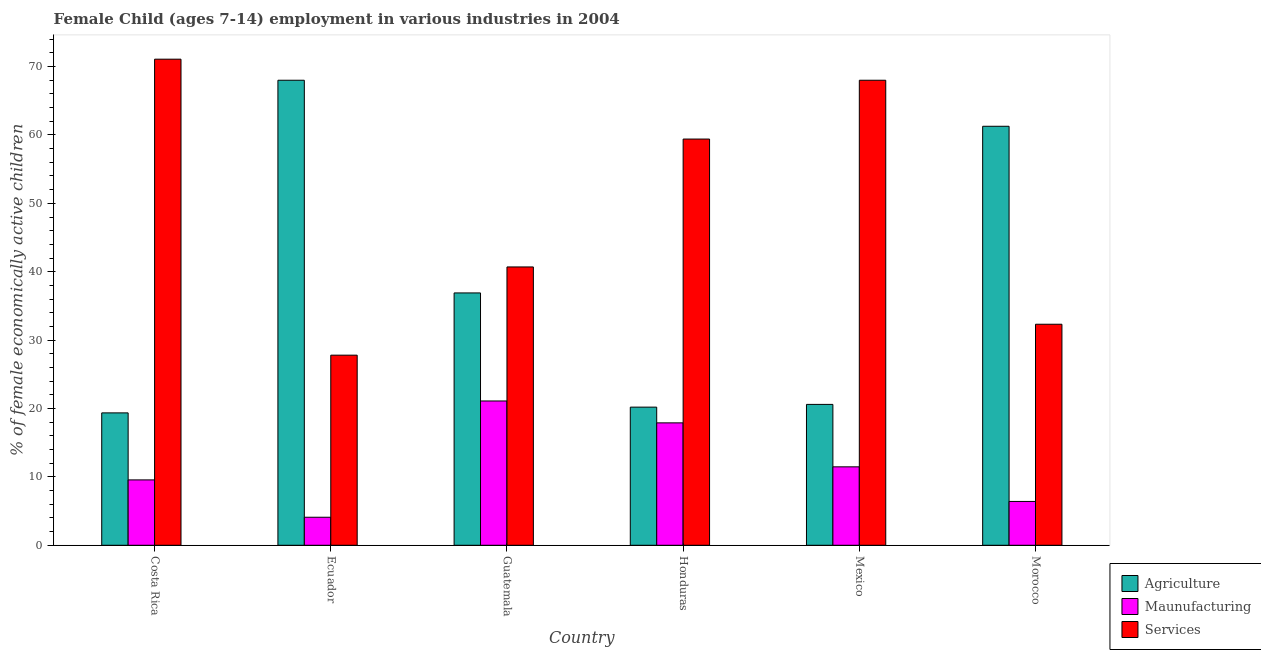How many different coloured bars are there?
Your answer should be compact. 3. Are the number of bars per tick equal to the number of legend labels?
Give a very brief answer. Yes. Are the number of bars on each tick of the X-axis equal?
Your answer should be very brief. Yes. How many bars are there on the 1st tick from the left?
Ensure brevity in your answer.  3. How many bars are there on the 2nd tick from the right?
Provide a short and direct response. 3. In how many cases, is the number of bars for a given country not equal to the number of legend labels?
Keep it short and to the point. 0. What is the percentage of economically active children in manufacturing in Morocco?
Ensure brevity in your answer.  6.41. Across all countries, what is the maximum percentage of economically active children in manufacturing?
Make the answer very short. 21.1. In which country was the percentage of economically active children in services minimum?
Offer a terse response. Ecuador. What is the total percentage of economically active children in agriculture in the graph?
Keep it short and to the point. 226.33. What is the difference between the percentage of economically active children in manufacturing in Guatemala and that in Honduras?
Your answer should be compact. 3.2. What is the difference between the percentage of economically active children in manufacturing in Honduras and the percentage of economically active children in agriculture in Guatemala?
Provide a succinct answer. -19. What is the average percentage of economically active children in services per country?
Your answer should be compact. 49.88. What is the difference between the percentage of economically active children in services and percentage of economically active children in agriculture in Costa Rica?
Ensure brevity in your answer.  51.72. In how many countries, is the percentage of economically active children in manufacturing greater than 46 %?
Provide a short and direct response. 0. What is the ratio of the percentage of economically active children in services in Ecuador to that in Honduras?
Give a very brief answer. 0.47. Is the percentage of economically active children in manufacturing in Ecuador less than that in Mexico?
Ensure brevity in your answer.  Yes. What is the difference between the highest and the second highest percentage of economically active children in agriculture?
Provide a short and direct response. 6.73. What is the difference between the highest and the lowest percentage of economically active children in manufacturing?
Make the answer very short. 17. In how many countries, is the percentage of economically active children in services greater than the average percentage of economically active children in services taken over all countries?
Provide a short and direct response. 3. Is the sum of the percentage of economically active children in agriculture in Ecuador and Mexico greater than the maximum percentage of economically active children in services across all countries?
Keep it short and to the point. Yes. What does the 3rd bar from the left in Morocco represents?
Your answer should be compact. Services. What does the 1st bar from the right in Mexico represents?
Offer a terse response. Services. How many bars are there?
Give a very brief answer. 18. Are the values on the major ticks of Y-axis written in scientific E-notation?
Your response must be concise. No. Does the graph contain grids?
Ensure brevity in your answer.  No. How many legend labels are there?
Provide a succinct answer. 3. How are the legend labels stacked?
Offer a terse response. Vertical. What is the title of the graph?
Provide a succinct answer. Female Child (ages 7-14) employment in various industries in 2004. Does "Injury" appear as one of the legend labels in the graph?
Give a very brief answer. No. What is the label or title of the Y-axis?
Your answer should be compact. % of female economically active children. What is the % of female economically active children in Agriculture in Costa Rica?
Keep it short and to the point. 19.36. What is the % of female economically active children of Maunufacturing in Costa Rica?
Your answer should be compact. 9.56. What is the % of female economically active children of Services in Costa Rica?
Your response must be concise. 71.08. What is the % of female economically active children in Agriculture in Ecuador?
Keep it short and to the point. 68. What is the % of female economically active children of Maunufacturing in Ecuador?
Offer a terse response. 4.1. What is the % of female economically active children of Services in Ecuador?
Provide a short and direct response. 27.8. What is the % of female economically active children of Agriculture in Guatemala?
Provide a succinct answer. 36.9. What is the % of female economically active children in Maunufacturing in Guatemala?
Offer a terse response. 21.1. What is the % of female economically active children in Services in Guatemala?
Your response must be concise. 40.7. What is the % of female economically active children in Agriculture in Honduras?
Provide a succinct answer. 20.2. What is the % of female economically active children in Services in Honduras?
Your response must be concise. 59.4. What is the % of female economically active children of Agriculture in Mexico?
Provide a short and direct response. 20.6. What is the % of female economically active children of Maunufacturing in Mexico?
Offer a very short reply. 11.47. What is the % of female economically active children of Agriculture in Morocco?
Your response must be concise. 61.27. What is the % of female economically active children in Maunufacturing in Morocco?
Keep it short and to the point. 6.41. What is the % of female economically active children in Services in Morocco?
Your answer should be very brief. 32.32. Across all countries, what is the maximum % of female economically active children in Maunufacturing?
Ensure brevity in your answer.  21.1. Across all countries, what is the maximum % of female economically active children of Services?
Offer a very short reply. 71.08. Across all countries, what is the minimum % of female economically active children of Agriculture?
Keep it short and to the point. 19.36. Across all countries, what is the minimum % of female economically active children of Maunufacturing?
Keep it short and to the point. 4.1. Across all countries, what is the minimum % of female economically active children of Services?
Offer a very short reply. 27.8. What is the total % of female economically active children of Agriculture in the graph?
Your response must be concise. 226.33. What is the total % of female economically active children of Maunufacturing in the graph?
Offer a very short reply. 70.54. What is the total % of female economically active children of Services in the graph?
Ensure brevity in your answer.  299.3. What is the difference between the % of female economically active children of Agriculture in Costa Rica and that in Ecuador?
Provide a succinct answer. -48.64. What is the difference between the % of female economically active children of Maunufacturing in Costa Rica and that in Ecuador?
Your answer should be compact. 5.46. What is the difference between the % of female economically active children in Services in Costa Rica and that in Ecuador?
Offer a very short reply. 43.28. What is the difference between the % of female economically active children of Agriculture in Costa Rica and that in Guatemala?
Your answer should be compact. -17.54. What is the difference between the % of female economically active children of Maunufacturing in Costa Rica and that in Guatemala?
Make the answer very short. -11.54. What is the difference between the % of female economically active children in Services in Costa Rica and that in Guatemala?
Your answer should be compact. 30.38. What is the difference between the % of female economically active children of Agriculture in Costa Rica and that in Honduras?
Your answer should be compact. -0.84. What is the difference between the % of female economically active children of Maunufacturing in Costa Rica and that in Honduras?
Provide a succinct answer. -8.34. What is the difference between the % of female economically active children in Services in Costa Rica and that in Honduras?
Your answer should be compact. 11.68. What is the difference between the % of female economically active children in Agriculture in Costa Rica and that in Mexico?
Your answer should be compact. -1.24. What is the difference between the % of female economically active children of Maunufacturing in Costa Rica and that in Mexico?
Provide a succinct answer. -1.91. What is the difference between the % of female economically active children of Services in Costa Rica and that in Mexico?
Provide a short and direct response. 3.08. What is the difference between the % of female economically active children of Agriculture in Costa Rica and that in Morocco?
Your answer should be compact. -41.91. What is the difference between the % of female economically active children of Maunufacturing in Costa Rica and that in Morocco?
Give a very brief answer. 3.15. What is the difference between the % of female economically active children in Services in Costa Rica and that in Morocco?
Ensure brevity in your answer.  38.76. What is the difference between the % of female economically active children of Agriculture in Ecuador and that in Guatemala?
Offer a very short reply. 31.1. What is the difference between the % of female economically active children of Maunufacturing in Ecuador and that in Guatemala?
Your answer should be compact. -17. What is the difference between the % of female economically active children in Services in Ecuador and that in Guatemala?
Your response must be concise. -12.9. What is the difference between the % of female economically active children in Agriculture in Ecuador and that in Honduras?
Your response must be concise. 47.8. What is the difference between the % of female economically active children of Maunufacturing in Ecuador and that in Honduras?
Offer a very short reply. -13.8. What is the difference between the % of female economically active children of Services in Ecuador and that in Honduras?
Give a very brief answer. -31.6. What is the difference between the % of female economically active children in Agriculture in Ecuador and that in Mexico?
Make the answer very short. 47.4. What is the difference between the % of female economically active children of Maunufacturing in Ecuador and that in Mexico?
Give a very brief answer. -7.37. What is the difference between the % of female economically active children in Services in Ecuador and that in Mexico?
Offer a very short reply. -40.2. What is the difference between the % of female economically active children in Agriculture in Ecuador and that in Morocco?
Offer a very short reply. 6.73. What is the difference between the % of female economically active children of Maunufacturing in Ecuador and that in Morocco?
Make the answer very short. -2.31. What is the difference between the % of female economically active children in Services in Ecuador and that in Morocco?
Make the answer very short. -4.52. What is the difference between the % of female economically active children in Agriculture in Guatemala and that in Honduras?
Your answer should be compact. 16.7. What is the difference between the % of female economically active children of Services in Guatemala and that in Honduras?
Ensure brevity in your answer.  -18.7. What is the difference between the % of female economically active children in Maunufacturing in Guatemala and that in Mexico?
Give a very brief answer. 9.63. What is the difference between the % of female economically active children of Services in Guatemala and that in Mexico?
Offer a terse response. -27.3. What is the difference between the % of female economically active children in Agriculture in Guatemala and that in Morocco?
Make the answer very short. -24.37. What is the difference between the % of female economically active children in Maunufacturing in Guatemala and that in Morocco?
Provide a succinct answer. 14.69. What is the difference between the % of female economically active children in Services in Guatemala and that in Morocco?
Offer a terse response. 8.38. What is the difference between the % of female economically active children in Agriculture in Honduras and that in Mexico?
Offer a very short reply. -0.4. What is the difference between the % of female economically active children in Maunufacturing in Honduras and that in Mexico?
Make the answer very short. 6.43. What is the difference between the % of female economically active children in Agriculture in Honduras and that in Morocco?
Provide a short and direct response. -41.07. What is the difference between the % of female economically active children in Maunufacturing in Honduras and that in Morocco?
Keep it short and to the point. 11.49. What is the difference between the % of female economically active children in Services in Honduras and that in Morocco?
Offer a terse response. 27.08. What is the difference between the % of female economically active children in Agriculture in Mexico and that in Morocco?
Your answer should be compact. -40.67. What is the difference between the % of female economically active children in Maunufacturing in Mexico and that in Morocco?
Your response must be concise. 5.06. What is the difference between the % of female economically active children of Services in Mexico and that in Morocco?
Your answer should be compact. 35.68. What is the difference between the % of female economically active children in Agriculture in Costa Rica and the % of female economically active children in Maunufacturing in Ecuador?
Provide a succinct answer. 15.26. What is the difference between the % of female economically active children of Agriculture in Costa Rica and the % of female economically active children of Services in Ecuador?
Keep it short and to the point. -8.44. What is the difference between the % of female economically active children of Maunufacturing in Costa Rica and the % of female economically active children of Services in Ecuador?
Offer a very short reply. -18.24. What is the difference between the % of female economically active children of Agriculture in Costa Rica and the % of female economically active children of Maunufacturing in Guatemala?
Keep it short and to the point. -1.74. What is the difference between the % of female economically active children in Agriculture in Costa Rica and the % of female economically active children in Services in Guatemala?
Your answer should be very brief. -21.34. What is the difference between the % of female economically active children of Maunufacturing in Costa Rica and the % of female economically active children of Services in Guatemala?
Ensure brevity in your answer.  -31.14. What is the difference between the % of female economically active children of Agriculture in Costa Rica and the % of female economically active children of Maunufacturing in Honduras?
Keep it short and to the point. 1.46. What is the difference between the % of female economically active children in Agriculture in Costa Rica and the % of female economically active children in Services in Honduras?
Make the answer very short. -40.04. What is the difference between the % of female economically active children of Maunufacturing in Costa Rica and the % of female economically active children of Services in Honduras?
Your answer should be very brief. -49.84. What is the difference between the % of female economically active children of Agriculture in Costa Rica and the % of female economically active children of Maunufacturing in Mexico?
Your response must be concise. 7.89. What is the difference between the % of female economically active children of Agriculture in Costa Rica and the % of female economically active children of Services in Mexico?
Provide a short and direct response. -48.64. What is the difference between the % of female economically active children in Maunufacturing in Costa Rica and the % of female economically active children in Services in Mexico?
Offer a very short reply. -58.44. What is the difference between the % of female economically active children in Agriculture in Costa Rica and the % of female economically active children in Maunufacturing in Morocco?
Ensure brevity in your answer.  12.95. What is the difference between the % of female economically active children in Agriculture in Costa Rica and the % of female economically active children in Services in Morocco?
Your answer should be very brief. -12.96. What is the difference between the % of female economically active children in Maunufacturing in Costa Rica and the % of female economically active children in Services in Morocco?
Your answer should be very brief. -22.76. What is the difference between the % of female economically active children in Agriculture in Ecuador and the % of female economically active children in Maunufacturing in Guatemala?
Keep it short and to the point. 46.9. What is the difference between the % of female economically active children of Agriculture in Ecuador and the % of female economically active children of Services in Guatemala?
Make the answer very short. 27.3. What is the difference between the % of female economically active children in Maunufacturing in Ecuador and the % of female economically active children in Services in Guatemala?
Your answer should be very brief. -36.6. What is the difference between the % of female economically active children of Agriculture in Ecuador and the % of female economically active children of Maunufacturing in Honduras?
Keep it short and to the point. 50.1. What is the difference between the % of female economically active children of Maunufacturing in Ecuador and the % of female economically active children of Services in Honduras?
Give a very brief answer. -55.3. What is the difference between the % of female economically active children of Agriculture in Ecuador and the % of female economically active children of Maunufacturing in Mexico?
Your response must be concise. 56.53. What is the difference between the % of female economically active children in Agriculture in Ecuador and the % of female economically active children in Services in Mexico?
Your answer should be very brief. 0. What is the difference between the % of female economically active children in Maunufacturing in Ecuador and the % of female economically active children in Services in Mexico?
Provide a short and direct response. -63.9. What is the difference between the % of female economically active children in Agriculture in Ecuador and the % of female economically active children in Maunufacturing in Morocco?
Your answer should be compact. 61.59. What is the difference between the % of female economically active children of Agriculture in Ecuador and the % of female economically active children of Services in Morocco?
Offer a very short reply. 35.68. What is the difference between the % of female economically active children in Maunufacturing in Ecuador and the % of female economically active children in Services in Morocco?
Offer a terse response. -28.22. What is the difference between the % of female economically active children in Agriculture in Guatemala and the % of female economically active children in Services in Honduras?
Your response must be concise. -22.5. What is the difference between the % of female economically active children of Maunufacturing in Guatemala and the % of female economically active children of Services in Honduras?
Offer a very short reply. -38.3. What is the difference between the % of female economically active children of Agriculture in Guatemala and the % of female economically active children of Maunufacturing in Mexico?
Give a very brief answer. 25.43. What is the difference between the % of female economically active children of Agriculture in Guatemala and the % of female economically active children of Services in Mexico?
Make the answer very short. -31.1. What is the difference between the % of female economically active children in Maunufacturing in Guatemala and the % of female economically active children in Services in Mexico?
Provide a short and direct response. -46.9. What is the difference between the % of female economically active children of Agriculture in Guatemala and the % of female economically active children of Maunufacturing in Morocco?
Keep it short and to the point. 30.49. What is the difference between the % of female economically active children in Agriculture in Guatemala and the % of female economically active children in Services in Morocco?
Offer a very short reply. 4.58. What is the difference between the % of female economically active children in Maunufacturing in Guatemala and the % of female economically active children in Services in Morocco?
Offer a terse response. -11.22. What is the difference between the % of female economically active children of Agriculture in Honduras and the % of female economically active children of Maunufacturing in Mexico?
Your response must be concise. 8.73. What is the difference between the % of female economically active children in Agriculture in Honduras and the % of female economically active children in Services in Mexico?
Give a very brief answer. -47.8. What is the difference between the % of female economically active children of Maunufacturing in Honduras and the % of female economically active children of Services in Mexico?
Provide a short and direct response. -50.1. What is the difference between the % of female economically active children in Agriculture in Honduras and the % of female economically active children in Maunufacturing in Morocco?
Ensure brevity in your answer.  13.79. What is the difference between the % of female economically active children of Agriculture in Honduras and the % of female economically active children of Services in Morocco?
Make the answer very short. -12.12. What is the difference between the % of female economically active children in Maunufacturing in Honduras and the % of female economically active children in Services in Morocco?
Offer a terse response. -14.42. What is the difference between the % of female economically active children in Agriculture in Mexico and the % of female economically active children in Maunufacturing in Morocco?
Ensure brevity in your answer.  14.19. What is the difference between the % of female economically active children of Agriculture in Mexico and the % of female economically active children of Services in Morocco?
Your answer should be compact. -11.72. What is the difference between the % of female economically active children in Maunufacturing in Mexico and the % of female economically active children in Services in Morocco?
Ensure brevity in your answer.  -20.85. What is the average % of female economically active children of Agriculture per country?
Give a very brief answer. 37.72. What is the average % of female economically active children in Maunufacturing per country?
Your answer should be very brief. 11.76. What is the average % of female economically active children of Services per country?
Offer a very short reply. 49.88. What is the difference between the % of female economically active children of Agriculture and % of female economically active children of Maunufacturing in Costa Rica?
Provide a short and direct response. 9.8. What is the difference between the % of female economically active children in Agriculture and % of female economically active children in Services in Costa Rica?
Give a very brief answer. -51.72. What is the difference between the % of female economically active children of Maunufacturing and % of female economically active children of Services in Costa Rica?
Your answer should be very brief. -61.52. What is the difference between the % of female economically active children in Agriculture and % of female economically active children in Maunufacturing in Ecuador?
Your answer should be compact. 63.9. What is the difference between the % of female economically active children in Agriculture and % of female economically active children in Services in Ecuador?
Offer a very short reply. 40.2. What is the difference between the % of female economically active children of Maunufacturing and % of female economically active children of Services in Ecuador?
Offer a terse response. -23.7. What is the difference between the % of female economically active children in Agriculture and % of female economically active children in Services in Guatemala?
Offer a very short reply. -3.8. What is the difference between the % of female economically active children in Maunufacturing and % of female economically active children in Services in Guatemala?
Make the answer very short. -19.6. What is the difference between the % of female economically active children in Agriculture and % of female economically active children in Services in Honduras?
Offer a very short reply. -39.2. What is the difference between the % of female economically active children in Maunufacturing and % of female economically active children in Services in Honduras?
Give a very brief answer. -41.5. What is the difference between the % of female economically active children of Agriculture and % of female economically active children of Maunufacturing in Mexico?
Provide a short and direct response. 9.13. What is the difference between the % of female economically active children of Agriculture and % of female economically active children of Services in Mexico?
Give a very brief answer. -47.4. What is the difference between the % of female economically active children in Maunufacturing and % of female economically active children in Services in Mexico?
Provide a succinct answer. -56.53. What is the difference between the % of female economically active children in Agriculture and % of female economically active children in Maunufacturing in Morocco?
Your response must be concise. 54.86. What is the difference between the % of female economically active children in Agriculture and % of female economically active children in Services in Morocco?
Offer a very short reply. 28.95. What is the difference between the % of female economically active children in Maunufacturing and % of female economically active children in Services in Morocco?
Make the answer very short. -25.91. What is the ratio of the % of female economically active children of Agriculture in Costa Rica to that in Ecuador?
Offer a very short reply. 0.28. What is the ratio of the % of female economically active children of Maunufacturing in Costa Rica to that in Ecuador?
Offer a very short reply. 2.33. What is the ratio of the % of female economically active children of Services in Costa Rica to that in Ecuador?
Your answer should be compact. 2.56. What is the ratio of the % of female economically active children of Agriculture in Costa Rica to that in Guatemala?
Ensure brevity in your answer.  0.52. What is the ratio of the % of female economically active children in Maunufacturing in Costa Rica to that in Guatemala?
Ensure brevity in your answer.  0.45. What is the ratio of the % of female economically active children of Services in Costa Rica to that in Guatemala?
Offer a very short reply. 1.75. What is the ratio of the % of female economically active children of Agriculture in Costa Rica to that in Honduras?
Ensure brevity in your answer.  0.96. What is the ratio of the % of female economically active children in Maunufacturing in Costa Rica to that in Honduras?
Keep it short and to the point. 0.53. What is the ratio of the % of female economically active children of Services in Costa Rica to that in Honduras?
Your answer should be very brief. 1.2. What is the ratio of the % of female economically active children of Agriculture in Costa Rica to that in Mexico?
Your answer should be compact. 0.94. What is the ratio of the % of female economically active children in Maunufacturing in Costa Rica to that in Mexico?
Your answer should be compact. 0.83. What is the ratio of the % of female economically active children in Services in Costa Rica to that in Mexico?
Keep it short and to the point. 1.05. What is the ratio of the % of female economically active children in Agriculture in Costa Rica to that in Morocco?
Keep it short and to the point. 0.32. What is the ratio of the % of female economically active children of Maunufacturing in Costa Rica to that in Morocco?
Keep it short and to the point. 1.49. What is the ratio of the % of female economically active children of Services in Costa Rica to that in Morocco?
Provide a short and direct response. 2.2. What is the ratio of the % of female economically active children of Agriculture in Ecuador to that in Guatemala?
Provide a succinct answer. 1.84. What is the ratio of the % of female economically active children of Maunufacturing in Ecuador to that in Guatemala?
Keep it short and to the point. 0.19. What is the ratio of the % of female economically active children in Services in Ecuador to that in Guatemala?
Ensure brevity in your answer.  0.68. What is the ratio of the % of female economically active children of Agriculture in Ecuador to that in Honduras?
Offer a very short reply. 3.37. What is the ratio of the % of female economically active children of Maunufacturing in Ecuador to that in Honduras?
Give a very brief answer. 0.23. What is the ratio of the % of female economically active children of Services in Ecuador to that in Honduras?
Provide a succinct answer. 0.47. What is the ratio of the % of female economically active children of Agriculture in Ecuador to that in Mexico?
Offer a terse response. 3.3. What is the ratio of the % of female economically active children in Maunufacturing in Ecuador to that in Mexico?
Your answer should be compact. 0.36. What is the ratio of the % of female economically active children of Services in Ecuador to that in Mexico?
Ensure brevity in your answer.  0.41. What is the ratio of the % of female economically active children of Agriculture in Ecuador to that in Morocco?
Offer a very short reply. 1.11. What is the ratio of the % of female economically active children in Maunufacturing in Ecuador to that in Morocco?
Give a very brief answer. 0.64. What is the ratio of the % of female economically active children in Services in Ecuador to that in Morocco?
Ensure brevity in your answer.  0.86. What is the ratio of the % of female economically active children in Agriculture in Guatemala to that in Honduras?
Give a very brief answer. 1.83. What is the ratio of the % of female economically active children of Maunufacturing in Guatemala to that in Honduras?
Provide a short and direct response. 1.18. What is the ratio of the % of female economically active children of Services in Guatemala to that in Honduras?
Make the answer very short. 0.69. What is the ratio of the % of female economically active children of Agriculture in Guatemala to that in Mexico?
Provide a short and direct response. 1.79. What is the ratio of the % of female economically active children of Maunufacturing in Guatemala to that in Mexico?
Give a very brief answer. 1.84. What is the ratio of the % of female economically active children in Services in Guatemala to that in Mexico?
Your answer should be compact. 0.6. What is the ratio of the % of female economically active children in Agriculture in Guatemala to that in Morocco?
Offer a terse response. 0.6. What is the ratio of the % of female economically active children in Maunufacturing in Guatemala to that in Morocco?
Make the answer very short. 3.29. What is the ratio of the % of female economically active children of Services in Guatemala to that in Morocco?
Ensure brevity in your answer.  1.26. What is the ratio of the % of female economically active children in Agriculture in Honduras to that in Mexico?
Your answer should be very brief. 0.98. What is the ratio of the % of female economically active children in Maunufacturing in Honduras to that in Mexico?
Offer a terse response. 1.56. What is the ratio of the % of female economically active children in Services in Honduras to that in Mexico?
Offer a terse response. 0.87. What is the ratio of the % of female economically active children in Agriculture in Honduras to that in Morocco?
Ensure brevity in your answer.  0.33. What is the ratio of the % of female economically active children in Maunufacturing in Honduras to that in Morocco?
Your answer should be very brief. 2.79. What is the ratio of the % of female economically active children in Services in Honduras to that in Morocco?
Make the answer very short. 1.84. What is the ratio of the % of female economically active children in Agriculture in Mexico to that in Morocco?
Keep it short and to the point. 0.34. What is the ratio of the % of female economically active children in Maunufacturing in Mexico to that in Morocco?
Your answer should be very brief. 1.79. What is the ratio of the % of female economically active children in Services in Mexico to that in Morocco?
Your answer should be very brief. 2.1. What is the difference between the highest and the second highest % of female economically active children in Agriculture?
Your response must be concise. 6.73. What is the difference between the highest and the second highest % of female economically active children in Services?
Your answer should be compact. 3.08. What is the difference between the highest and the lowest % of female economically active children of Agriculture?
Provide a succinct answer. 48.64. What is the difference between the highest and the lowest % of female economically active children of Services?
Give a very brief answer. 43.28. 